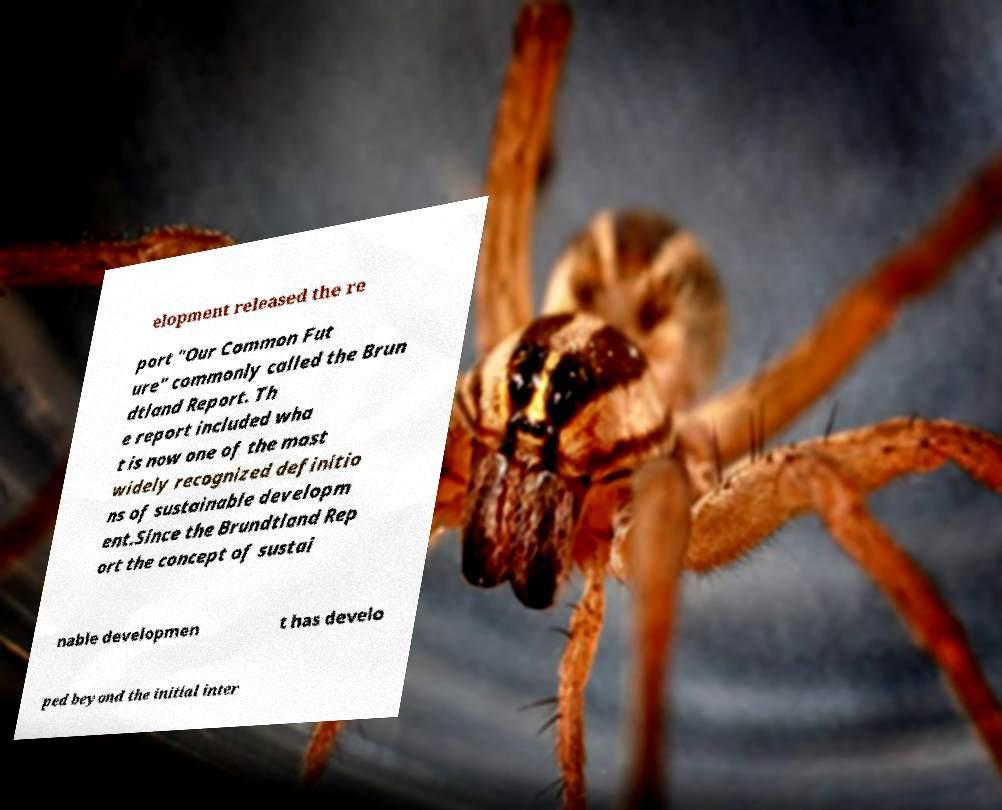Please read and relay the text visible in this image. What does it say? elopment released the re port "Our Common Fut ure" commonly called the Brun dtland Report. Th e report included wha t is now one of the most widely recognized definitio ns of sustainable developm ent.Since the Brundtland Rep ort the concept of sustai nable developmen t has develo ped beyond the initial inter 